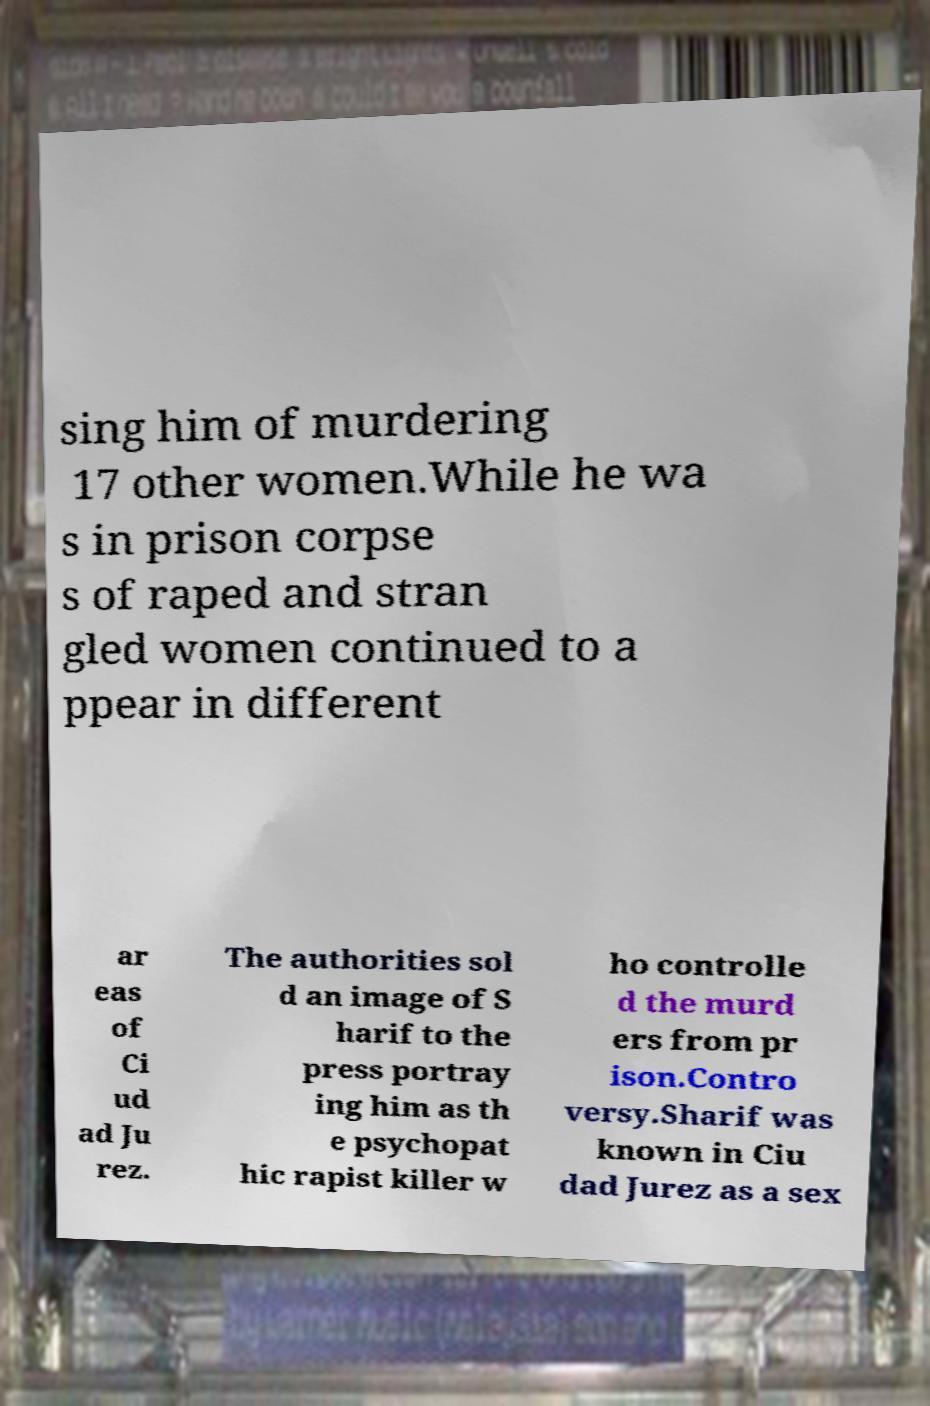Please identify and transcribe the text found in this image. sing him of murdering 17 other women.While he wa s in prison corpse s of raped and stran gled women continued to a ppear in different ar eas of Ci ud ad Ju rez. The authorities sol d an image of S harif to the press portray ing him as th e psychopat hic rapist killer w ho controlle d the murd ers from pr ison.Contro versy.Sharif was known in Ciu dad Jurez as a sex 